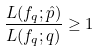Convert formula to latex. <formula><loc_0><loc_0><loc_500><loc_500>\frac { L ( f _ { q } ; \hat { p } ) } { L ( f _ { q } ; q ) } \geq 1</formula> 